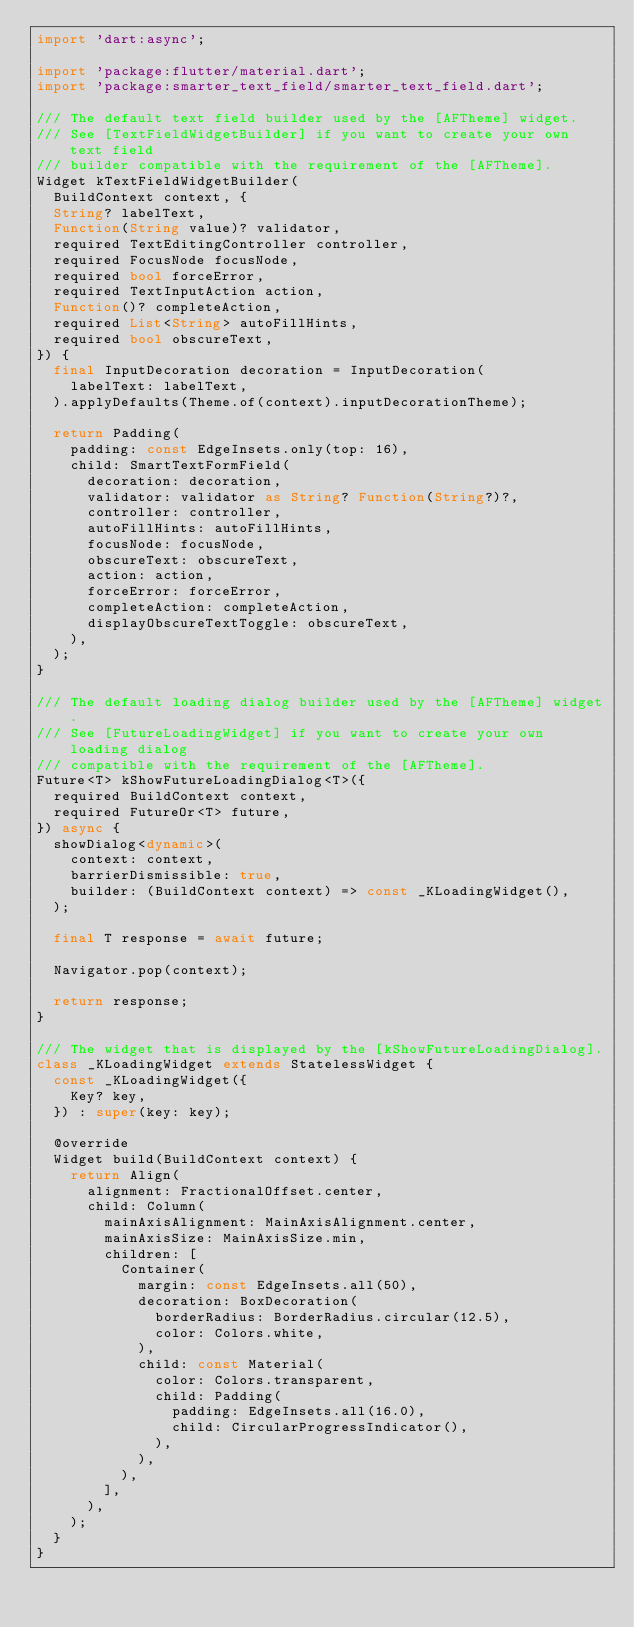<code> <loc_0><loc_0><loc_500><loc_500><_Dart_>import 'dart:async';

import 'package:flutter/material.dart';
import 'package:smarter_text_field/smarter_text_field.dart';

/// The default text field builder used by the [AFTheme] widget.
/// See [TextFieldWidgetBuilder] if you want to create your own text field
/// builder compatible with the requirement of the [AFTheme].
Widget kTextFieldWidgetBuilder(
  BuildContext context, {
  String? labelText,
  Function(String value)? validator,
  required TextEditingController controller,
  required FocusNode focusNode,
  required bool forceError,
  required TextInputAction action,
  Function()? completeAction,
  required List<String> autoFillHints,
  required bool obscureText,
}) {
  final InputDecoration decoration = InputDecoration(
    labelText: labelText,
  ).applyDefaults(Theme.of(context).inputDecorationTheme);

  return Padding(
    padding: const EdgeInsets.only(top: 16),
    child: SmartTextFormField(
      decoration: decoration,
      validator: validator as String? Function(String?)?,
      controller: controller,
      autoFillHints: autoFillHints,
      focusNode: focusNode,
      obscureText: obscureText,
      action: action,
      forceError: forceError,
      completeAction: completeAction,
      displayObscureTextToggle: obscureText,
    ),
  );
}

/// The default loading dialog builder used by the [AFTheme] widget.
/// See [FutureLoadingWidget] if you want to create your own loading dialog
/// compatible with the requirement of the [AFTheme].
Future<T> kShowFutureLoadingDialog<T>({
  required BuildContext context,
  required FutureOr<T> future,
}) async {
  showDialog<dynamic>(
    context: context,
    barrierDismissible: true,
    builder: (BuildContext context) => const _KLoadingWidget(),
  );

  final T response = await future;

  Navigator.pop(context);

  return response;
}

/// The widget that is displayed by the [kShowFutureLoadingDialog].
class _KLoadingWidget extends StatelessWidget {
  const _KLoadingWidget({
    Key? key,
  }) : super(key: key);

  @override
  Widget build(BuildContext context) {
    return Align(
      alignment: FractionalOffset.center,
      child: Column(
        mainAxisAlignment: MainAxisAlignment.center,
        mainAxisSize: MainAxisSize.min,
        children: [
          Container(
            margin: const EdgeInsets.all(50),
            decoration: BoxDecoration(
              borderRadius: BorderRadius.circular(12.5),
              color: Colors.white,
            ),
            child: const Material(
              color: Colors.transparent,
              child: Padding(
                padding: EdgeInsets.all(16.0),
                child: CircularProgressIndicator(),
              ),
            ),
          ),
        ],
      ),
    );
  }
}
</code> 